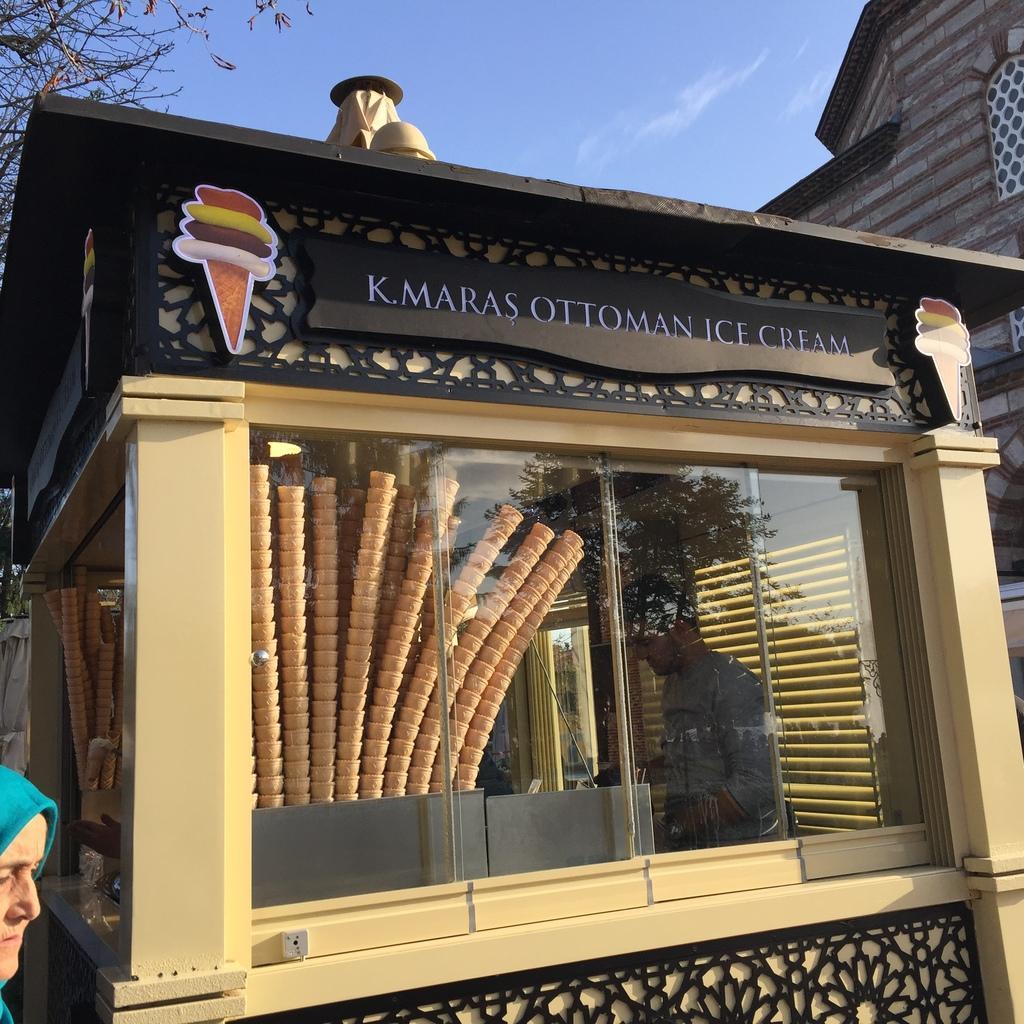In one or two sentences, can you explain what this image depicts? Sky is in blue color. This is ice-cream store. These are ice-cream cones. Inside this store there is a man. Here we can see a person and tree. Building with window. 